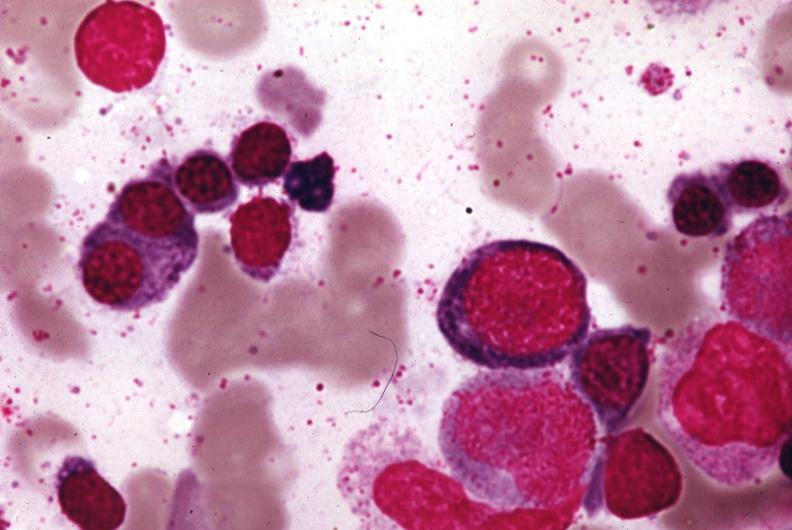does wrights stain?
Answer the question using a single word or phrase. Yes 